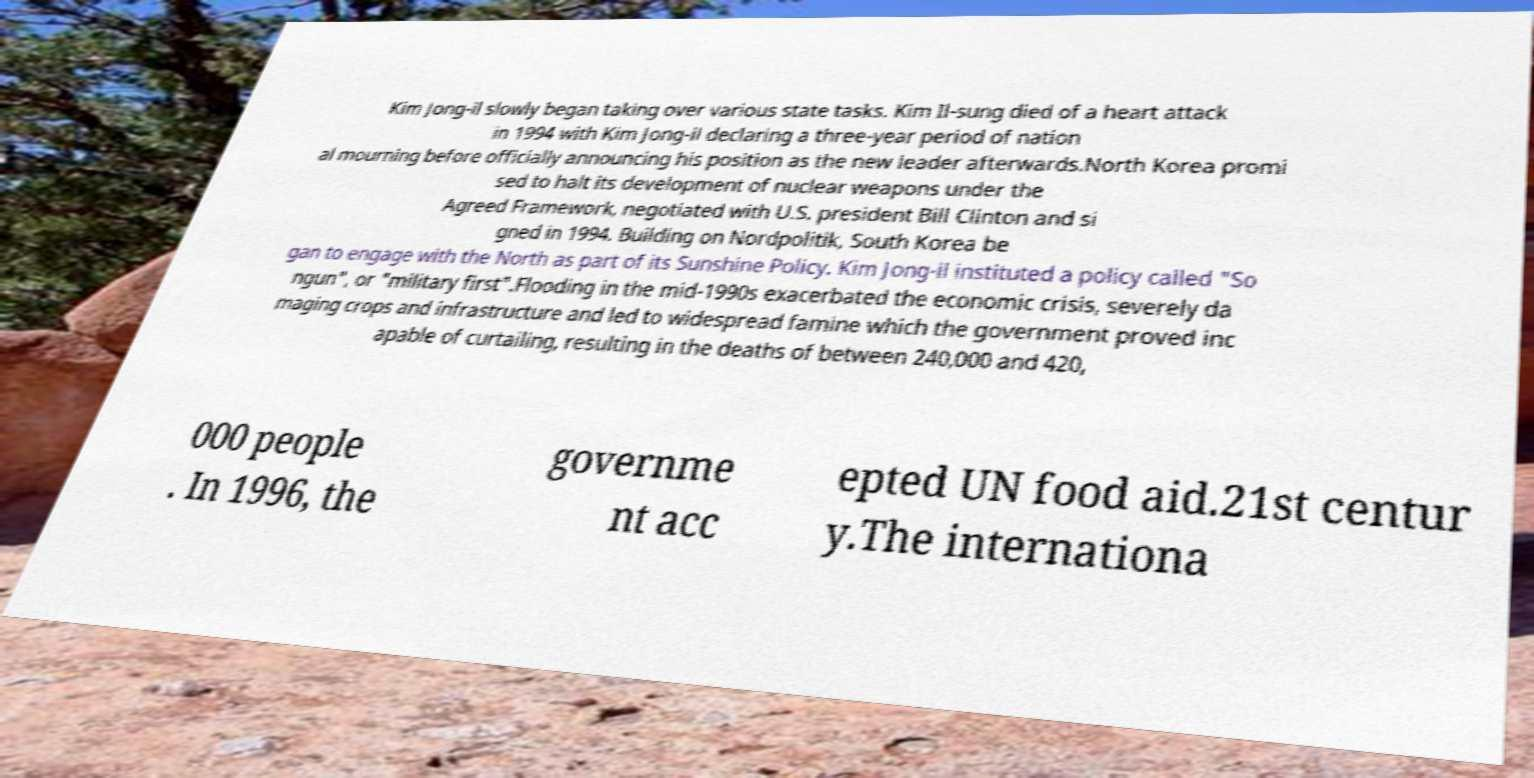Can you accurately transcribe the text from the provided image for me? Kim Jong-il slowly began taking over various state tasks. Kim Il-sung died of a heart attack in 1994 with Kim Jong-il declaring a three-year period of nation al mourning before officially announcing his position as the new leader afterwards.North Korea promi sed to halt its development of nuclear weapons under the Agreed Framework, negotiated with U.S. president Bill Clinton and si gned in 1994. Building on Nordpolitik, South Korea be gan to engage with the North as part of its Sunshine Policy. Kim Jong-il instituted a policy called "So ngun", or "military first".Flooding in the mid-1990s exacerbated the economic crisis, severely da maging crops and infrastructure and led to widespread famine which the government proved inc apable of curtailing, resulting in the deaths of between 240,000 and 420, 000 people . In 1996, the governme nt acc epted UN food aid.21st centur y.The internationa 